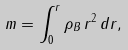<formula> <loc_0><loc_0><loc_500><loc_500>m = \int _ { 0 } ^ { r } \rho _ { B } \, r ^ { 2 } \, d r ,</formula> 